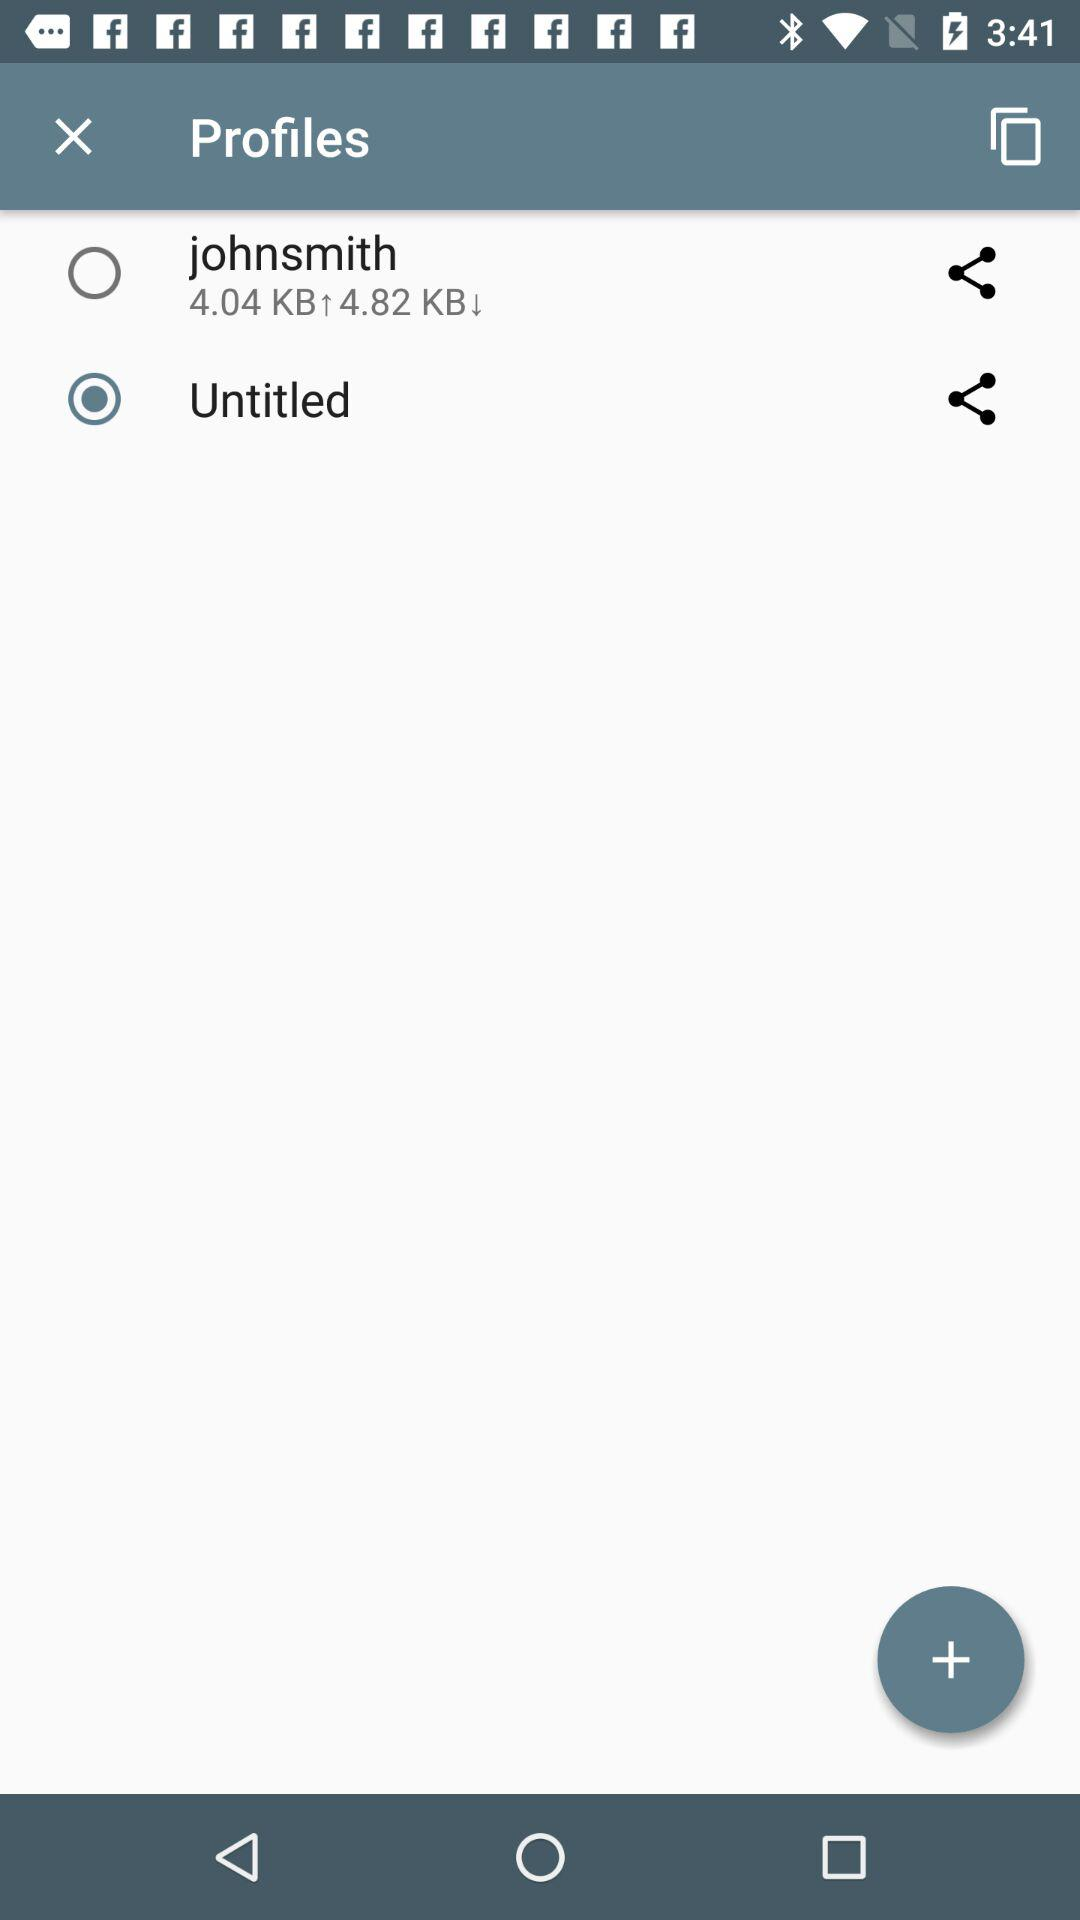What is the download speed? The download speed is 4.82 KB. 